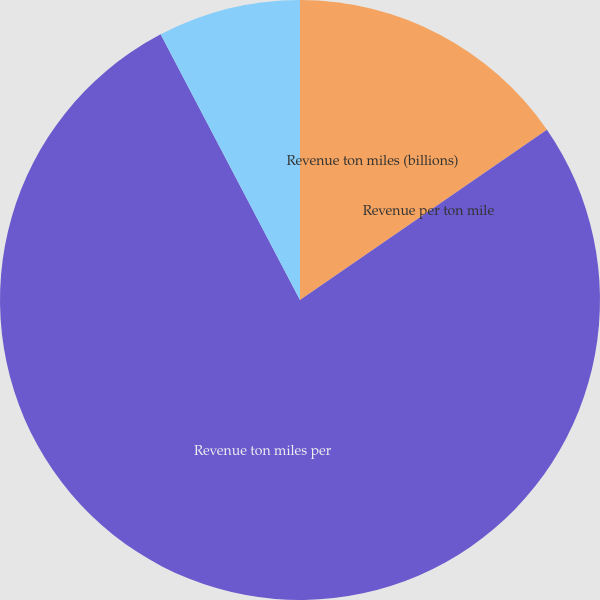Convert chart. <chart><loc_0><loc_0><loc_500><loc_500><pie_chart><fcel>Revenue ton miles (billions)<fcel>Revenue per ton mile<fcel>Revenue ton miles per<fcel>Ratio of railway operating<nl><fcel>15.39%<fcel>0.0%<fcel>76.92%<fcel>7.69%<nl></chart> 